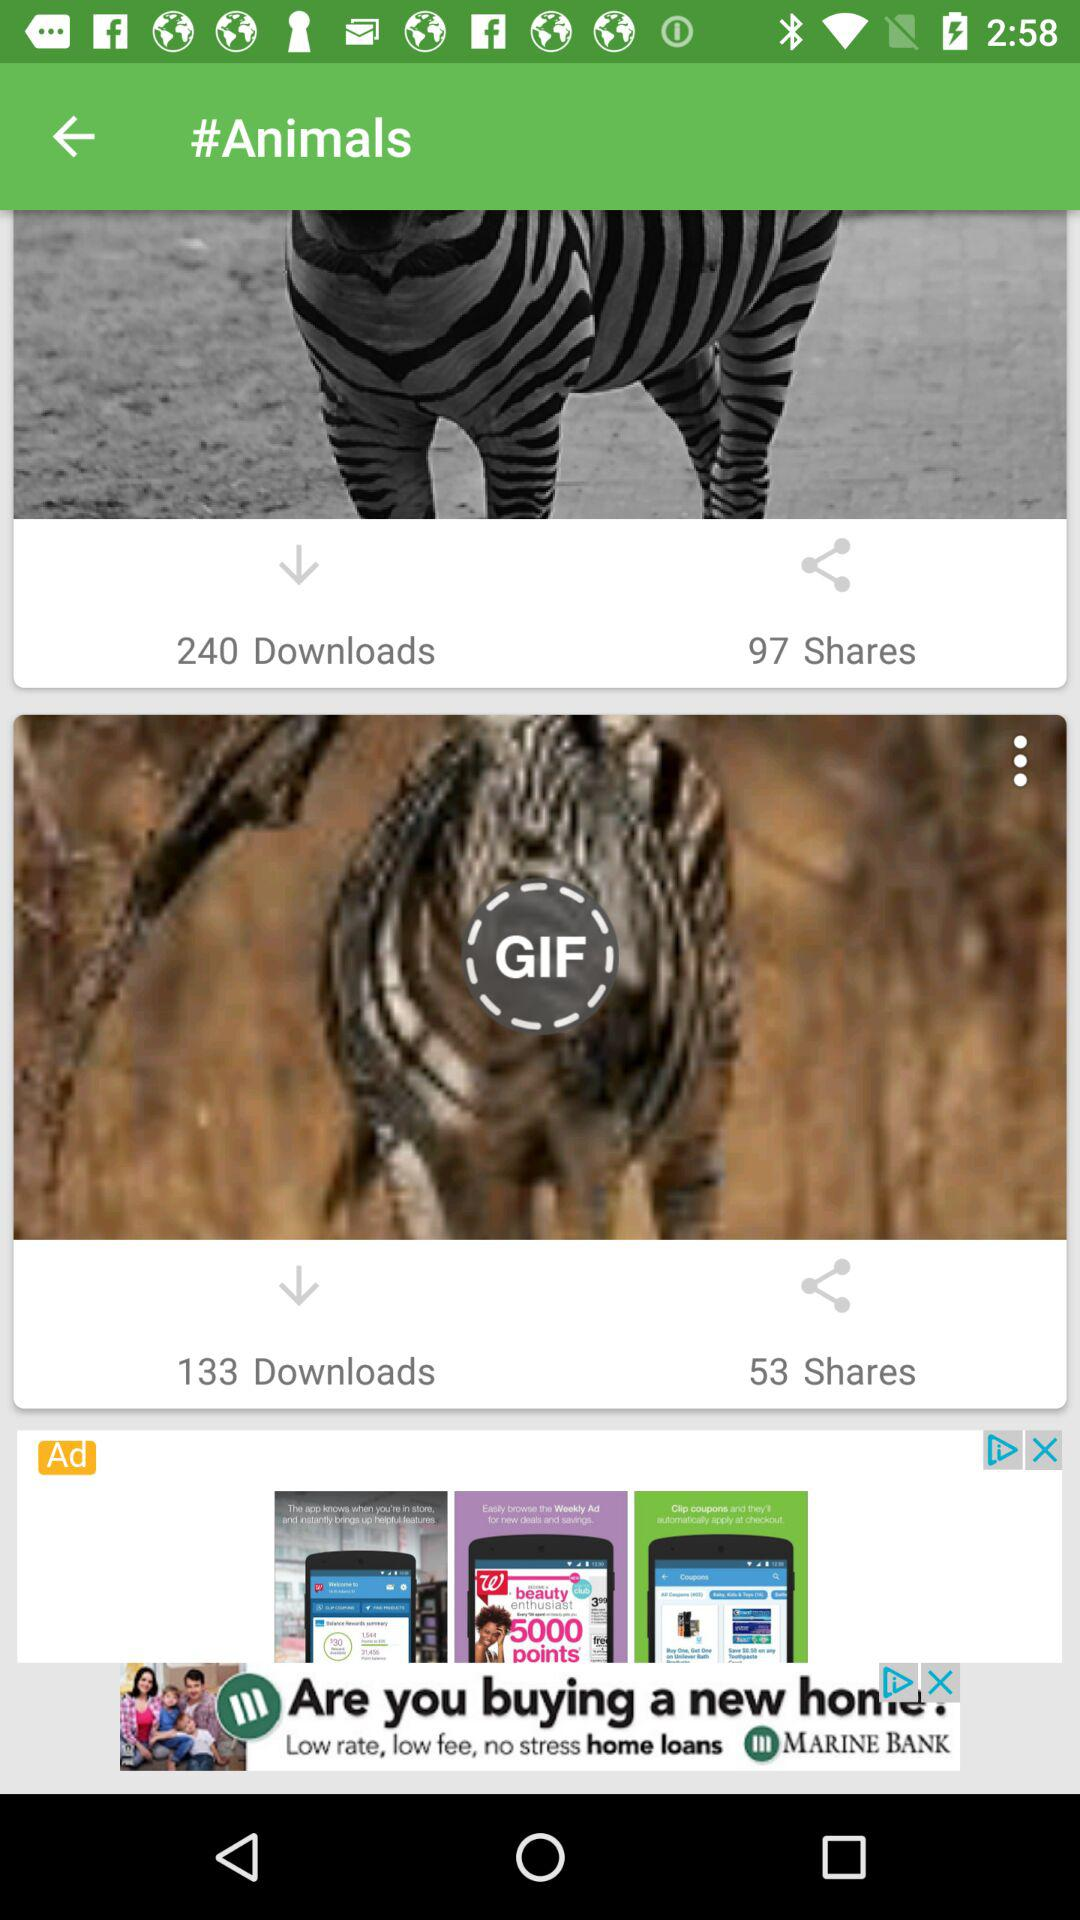How many GIFs are shared? There are 53 GIFs shared. 